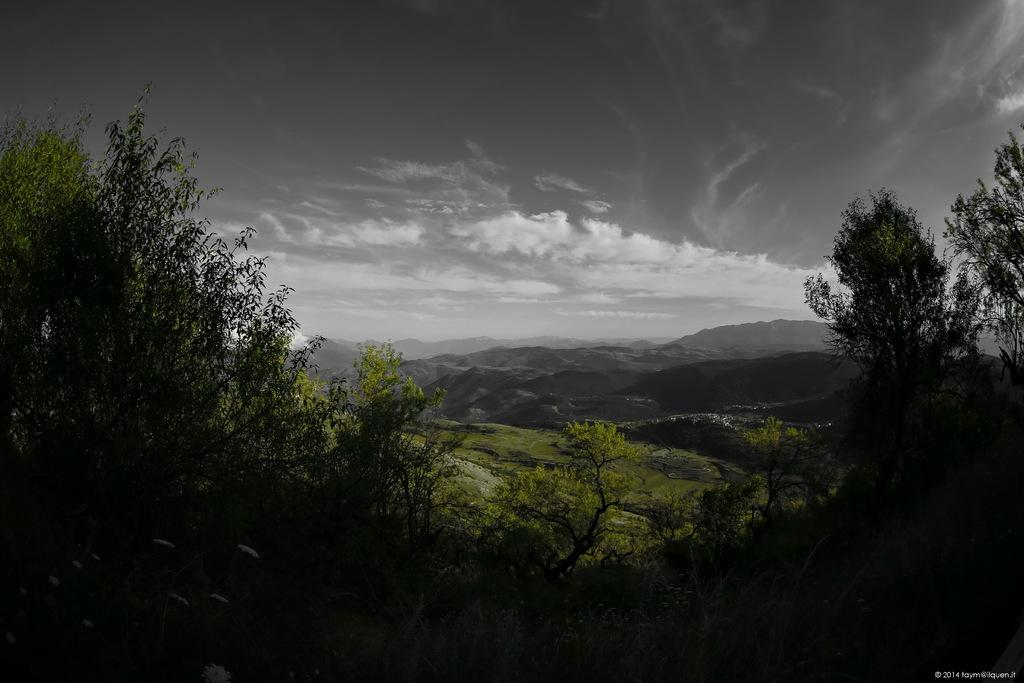What type of vegetation can be seen in the image? There are trees in the image. What can be seen in the distance in the image? There are hills visible in the background of the image. What part of the natural environment is visible in the image? The sky is visible in the background of the image. How many crates are stacked on top of each other in the image? There are no crates present in the image. 